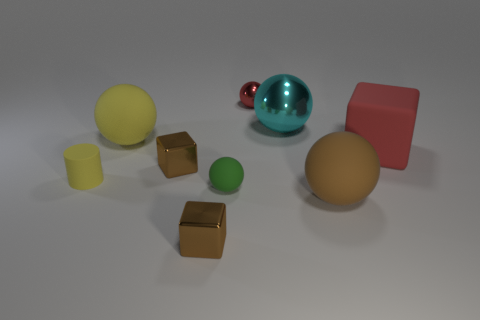Are there any matte cylinders that have the same color as the rubber block?
Your answer should be compact. No. There is a red thing behind the yellow ball on the left side of the metallic ball that is behind the cyan metallic object; what size is it?
Offer a terse response. Small. There is a cylinder that is the same material as the big yellow object; what size is it?
Your response must be concise. Small. What size is the ball that is the same color as the big matte cube?
Make the answer very short. Small. What is the size of the green sphere?
Provide a short and direct response. Small. What number of green blocks are there?
Your answer should be compact. 0. What shape is the brown thing that is to the right of the red ball?
Offer a very short reply. Sphere. How many other objects are the same size as the cyan metallic sphere?
Ensure brevity in your answer.  3. Do the brown shiny thing behind the green matte ball and the red object that is in front of the large yellow thing have the same shape?
Ensure brevity in your answer.  Yes. There is a tiny red shiny thing; how many small green spheres are behind it?
Provide a short and direct response. 0. 